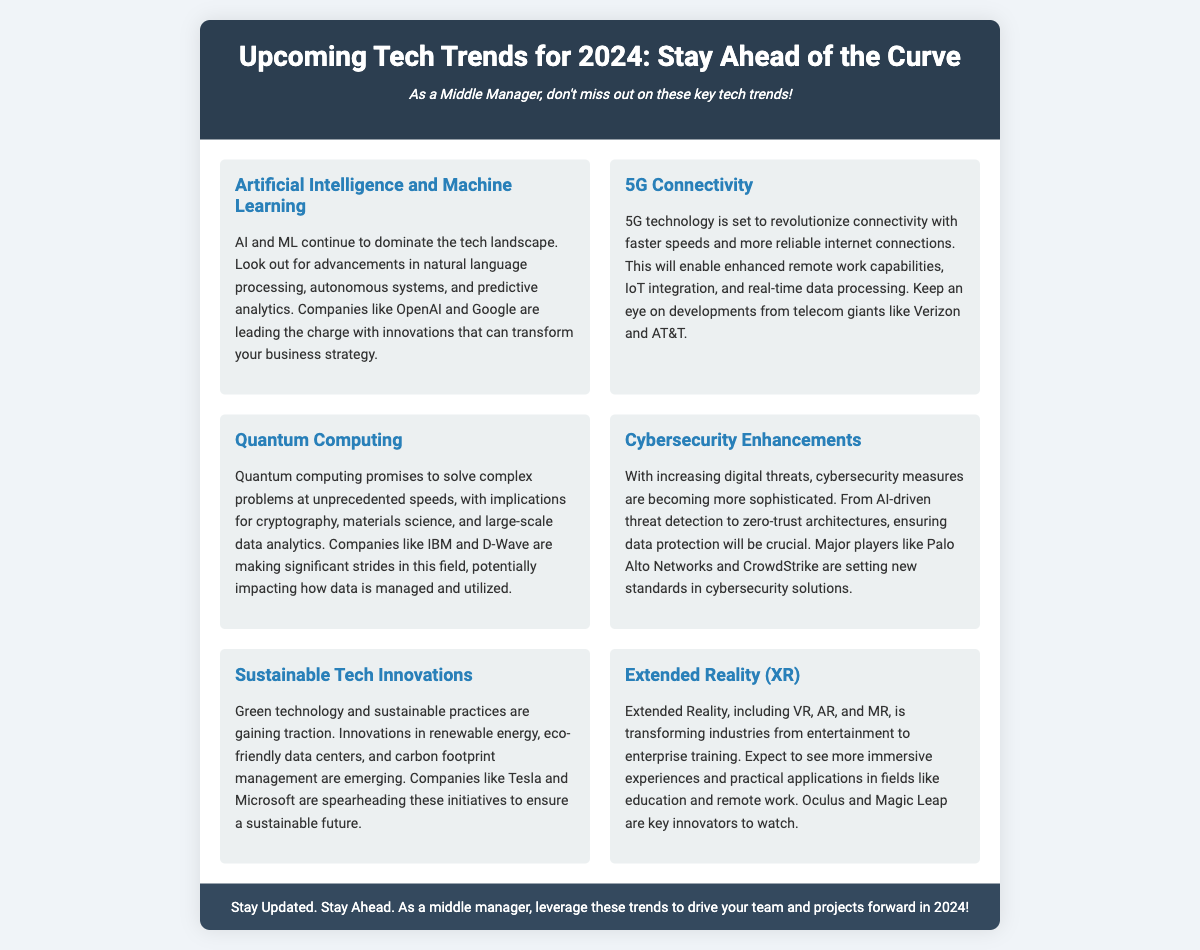What are the key tech trends for 2024? The flyer lists several key tech trends for 2024 including Artificial Intelligence, 5G Connectivity, Quantum Computing, Cybersecurity Enhancements, Sustainable Tech Innovations, and Extended Reality.
Answer: Artificial Intelligence, 5G Connectivity, Quantum Computing, Cybersecurity Enhancements, Sustainable Tech Innovations, Extended Reality Who are some companies leading in Artificial Intelligence advancements? According to the document, companies like OpenAI and Google are mentioned as leading advancements in Artificial Intelligence.
Answer: OpenAI and Google What technology is set to revolutionize connectivity? The flyer specifically mentions that 5G technology will revolutionize connectivity.
Answer: 5G technology Which company is mentioned as a key player in cybersecurity solutions? The document highlights Palo Alto Networks and CrowdStrike as major players in cybersecurity solutions.
Answer: Palo Alto Networks and CrowdStrike What is the significance of quantum computing? Quantum computing is significant for solving complex problems at unprecedented speeds and has implications for various fields according to the flyer.
Answer: Solve complex problems at unprecedented speeds What does XR stand for? The document refers to Extended Reality, which encompasses Virtual Reality, Augmented Reality, and Mixed Reality.
Answer: Extended Reality What sustainable initiatives are companies like Tesla and Microsoft focusing on? They are focusing on innovations in renewable energy, eco-friendly data centers, and carbon footprint management.
Answer: Renewable energy, eco-friendly data centers, carbon footprint management How do AI and ML impact business strategy? The document states that advancements in AI and ML can transform business strategy, indicating their significant impact.
Answer: Transform business strategy 